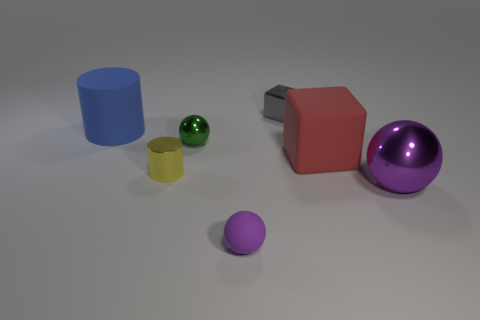Is the big sphere the same color as the small matte object?
Provide a succinct answer. Yes. There is a large thing in front of the matte cube; is it the same color as the small matte object?
Your response must be concise. Yes. What shape is the matte object behind the matte cube?
Keep it short and to the point. Cylinder. There is a shiny sphere that is in front of the big matte block; are there any blue rubber objects that are behind it?
Ensure brevity in your answer.  Yes. How many purple things have the same material as the yellow cylinder?
Your response must be concise. 1. What is the size of the gray object behind the purple sphere left of the cube that is behind the big red matte cube?
Offer a terse response. Small. There is a rubber cylinder; how many small green metallic spheres are in front of it?
Make the answer very short. 1. Is the number of tiny gray objects greater than the number of purple spheres?
Keep it short and to the point. No. There is a rubber sphere that is the same color as the large metal thing; what size is it?
Offer a very short reply. Small. How big is the thing that is both left of the matte sphere and in front of the green shiny sphere?
Give a very brief answer. Small. 